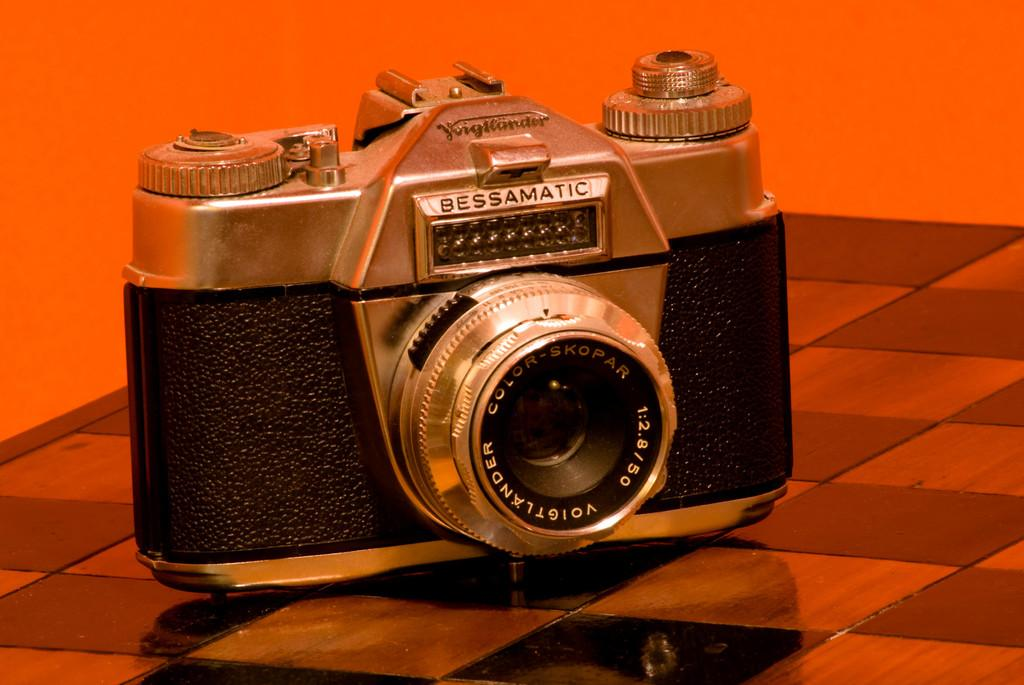What is the main object in the image? There is a camera in the image. What can be seen in the background of the image? There is an orange color wall in the background of the image. What type of stem can be seen growing from the camera in the image? There is no stem growing from the camera in the image. How is the camera connected to the farm in the image? There is no farm present in the image, and the camera is not connected to any farm. 